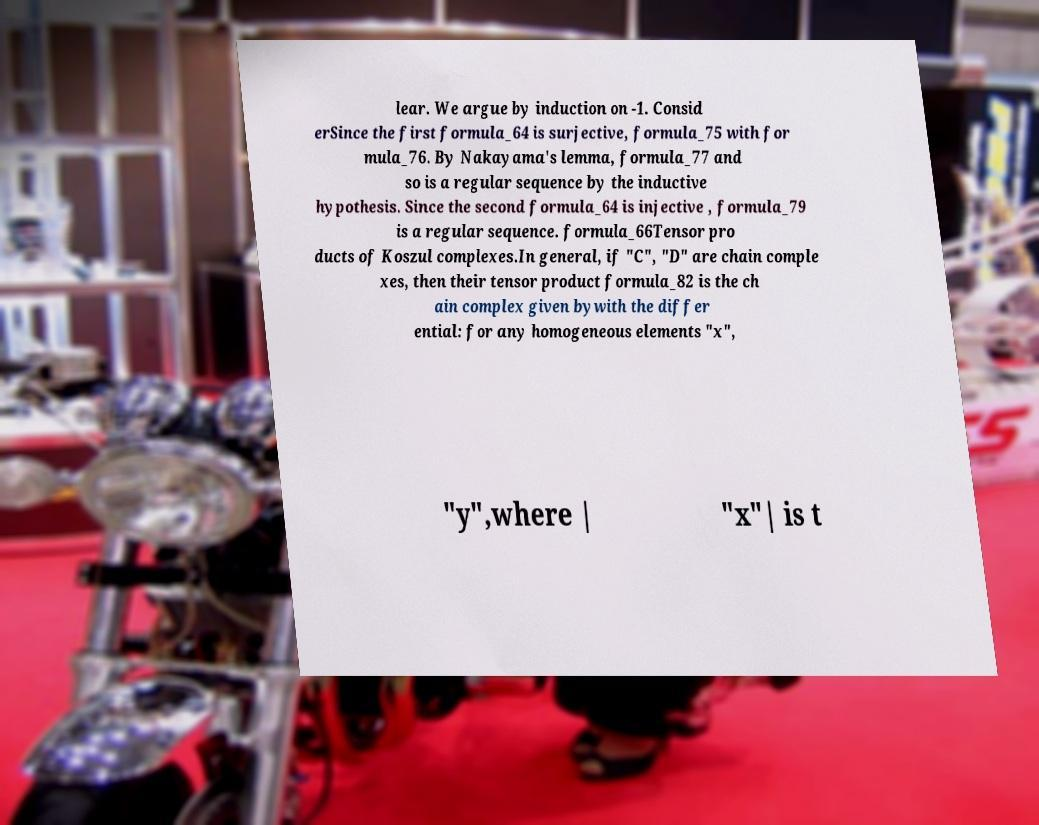Please read and relay the text visible in this image. What does it say? lear. We argue by induction on -1. Consid erSince the first formula_64 is surjective, formula_75 with for mula_76. By Nakayama's lemma, formula_77 and so is a regular sequence by the inductive hypothesis. Since the second formula_64 is injective , formula_79 is a regular sequence. formula_66Tensor pro ducts of Koszul complexes.In general, if "C", "D" are chain comple xes, then their tensor product formula_82 is the ch ain complex given bywith the differ ential: for any homogeneous elements "x", "y",where | "x"| is t 